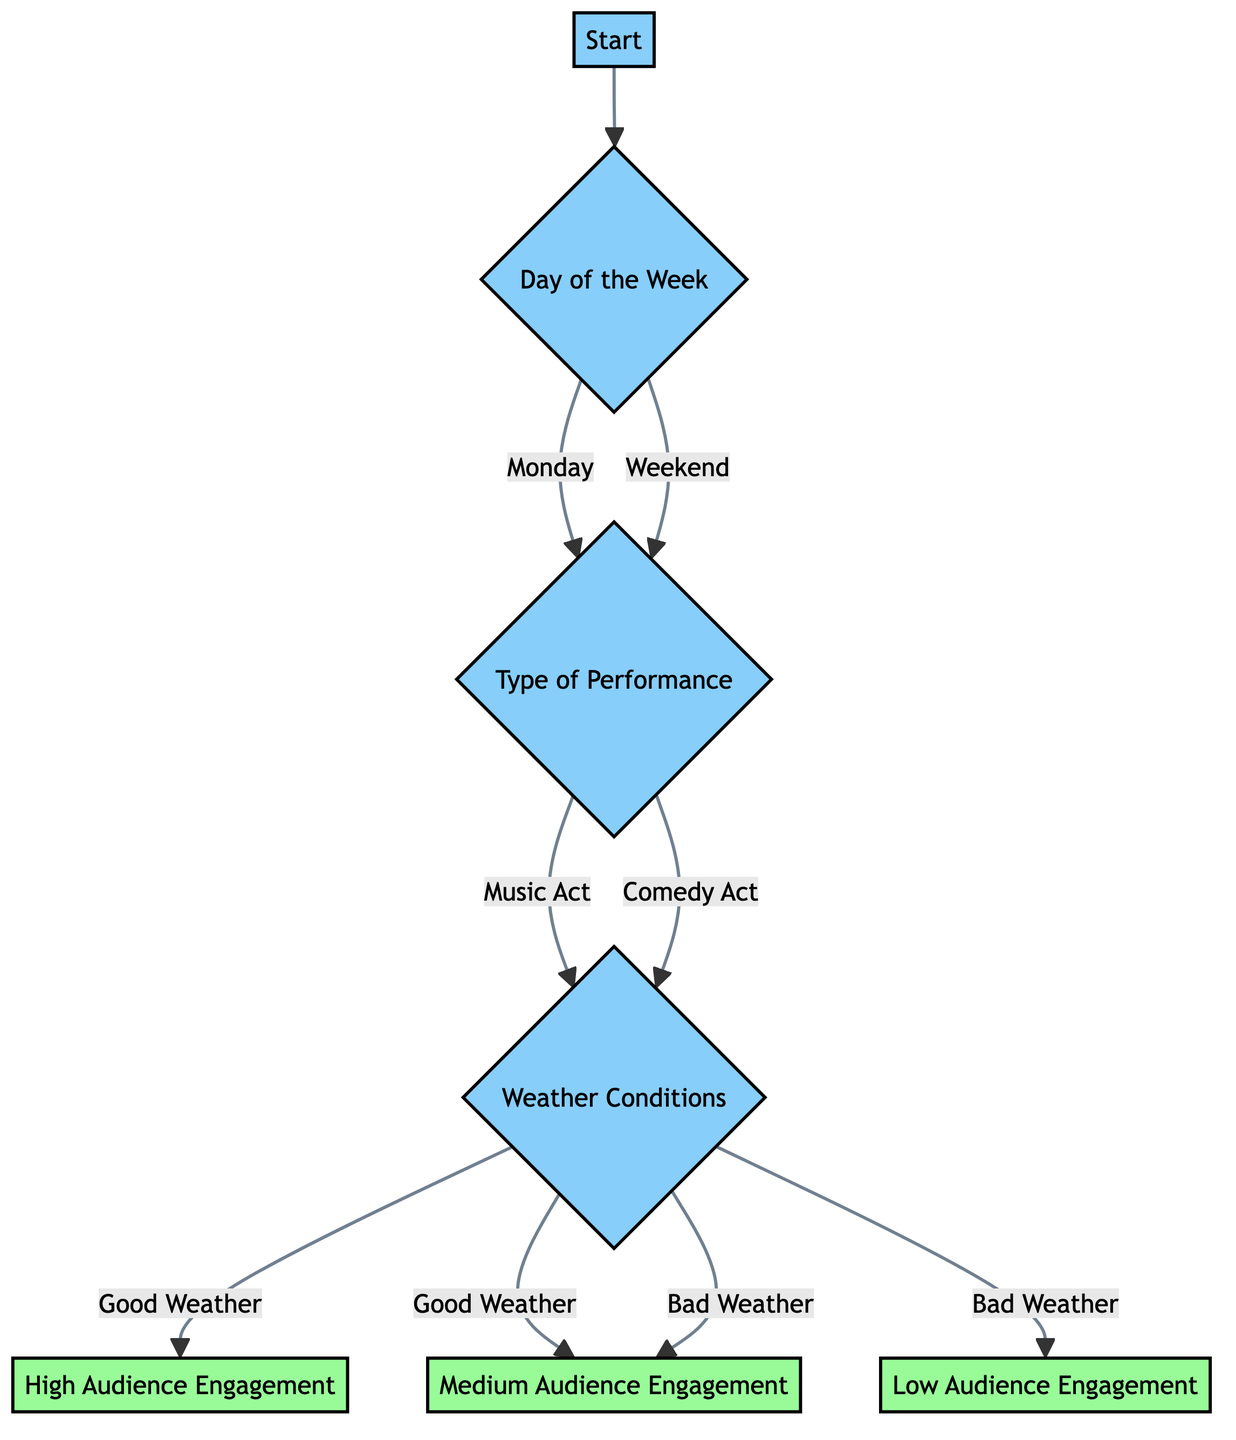What is the first decision point in the diagram? The first decision point in the diagram is "Day of the Week", as it is the initial node after "Start" that branches out to other nodes based on the day.
Answer: Day of the Week How many types of performances are considered in the diagram? The diagram distinguishes between two types of performances: "Music Act" and "Comedy Act." These are the two branches that emerge from the "Type of Performance" node.
Answer: Two What is the outcome if the performance type is a music act and the weather is good? According to the diagram, if the performance type is a music act and the weather conditions are good, the diagram leads to a "High Audience Engagement" outcome.
Answer: High Audience Engagement What happens if the day is a weekend? If the day is a weekend, the diagram branches into the "Type of Performance" node, similar to if the day were Monday, leading to performance types without affecting the outcome directly at this point.
Answer: Type of Performance What are the engagement levels for bad weather conditions? The diagram indicates that for bad weather conditions, the audience engagement can result in either "Medium Audience Engagement" or "Low Audience Engagement," depending on the type of performance.
Answer: Medium Audience Engagement, Low Audience Engagement How many leaf nodes are present in the diagram? The diagram contains three leaf nodes: "High Audience Engagement," "Medium Audience Engagement," and "Low Audience Engagement," which signify the final outcomes of the decision-making process.
Answer: Three What is the relationship between "Type of Performance" and "Weather Conditions"? "Type of Performance" serves as a condition that influences the next step, which is "Weather Conditions." Both performance types lead to the weather condition evaluations, indicating that weather is a factor after determining the type of performance.
Answer: Influential What does the diagram suggest about engagement on weekdays versus weekends? On weekdays, the decision branches depend on the day to evaluate performance type and subsequently weather, whereas on weekends, it also prompts performance type decision before weather considerations, suggesting potential variation in audience engagement.
Answer: Varies based on performance type 